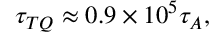Convert formula to latex. <formula><loc_0><loc_0><loc_500><loc_500>\tau _ { T Q } \approx 0 . 9 \times 1 0 ^ { 5 } \tau _ { A } ,</formula> 